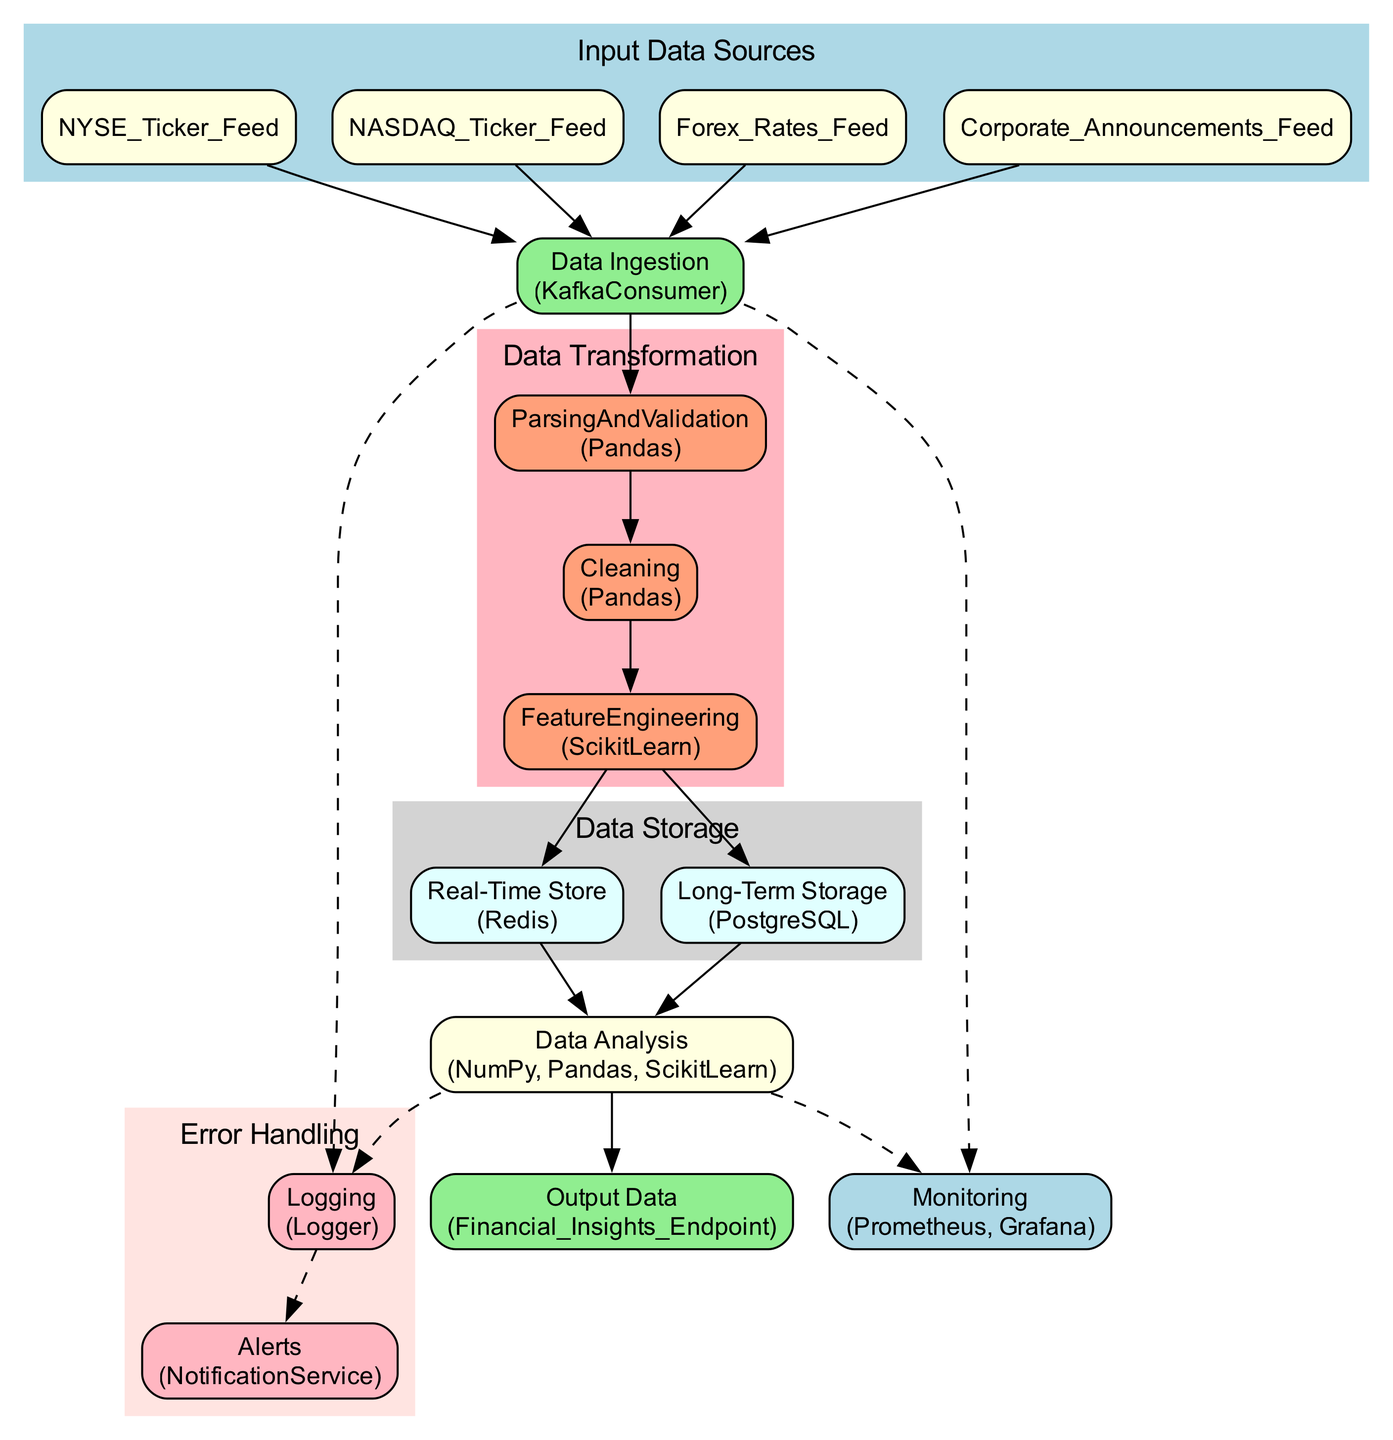What are the input data sources in the pipeline? The diagram lists four input data sources: NYSE Ticker Feed, NASDAQ Ticker Feed, Forex Rates Feed, and Corporate Announcements Feed. These are directly shown within the "Input Data Sources" cluster.
Answer: NYSE Ticker Feed, NASDAQ Ticker Feed, Forex Rates Feed, Corporate Announcements Feed What is the type of data ingestion used? The "Data Ingestion" node specifies it uses "KafkaConsumer" as its type, indicated in the diagram.
Answer: KafkaConsumer How many stages are there in the data transformation process? The diagram shows three distinct stages in the "Data Transformation" section: Parsing and Validation, Cleaning, and Feature Engineering. Counting these stages gives us three.
Answer: 3 What are the libraries used in the data analysis stage? The "Data Analysis" node in the diagram indicates the libraries used are NumPy, Pandas, and ScikitLearn, which are listed directly in that section.
Answer: NumPy, Pandas, ScikitLearn Which data storage method is used for real-time data? The "Real-Time Store" node under "Data Storage" indicates that Redis is the method used for real-time data storage, as specified in the diagram.
Answer: Redis What is the output of the data pipeline? According to the diagram, the output of the data pipeline is directed towards the "Financial Insights Endpoint," which is identified in the "Output Data" node.
Answer: Financial Insights Endpoint How does the data flow from data ingestion to data analysis? The diagram shows the transition from Data Ingestion to Parsing and Validation, then to Cleaning, followed by Feature Engineering, and finally leading to both Real-Time Store and Long-Term Storage, which connect to Data Analysis. This sequential flow highlights how data moves through these stages to reach the analysis step.
Answer: Data Ingestion → Parsing and Validation → Cleaning → Feature Engineering → RealTimeStore, LongTermStorage → Data Analysis What error handling methods are utilized in the pipeline? The diagram outlines two error handling methods: Logging and Alerts. Logging uses a Logger, while Alerts employ a Notification Service, as indicated in the "Error Handling" cluster.
Answer: Logging, Alerts What monitoring tools are integrated within the data pipeline? The "Monitoring" node indicates that Prometheus and Grafana are the tools used for monitoring, which are specified in the associated section of the diagram.
Answer: Prometheus, Grafana 